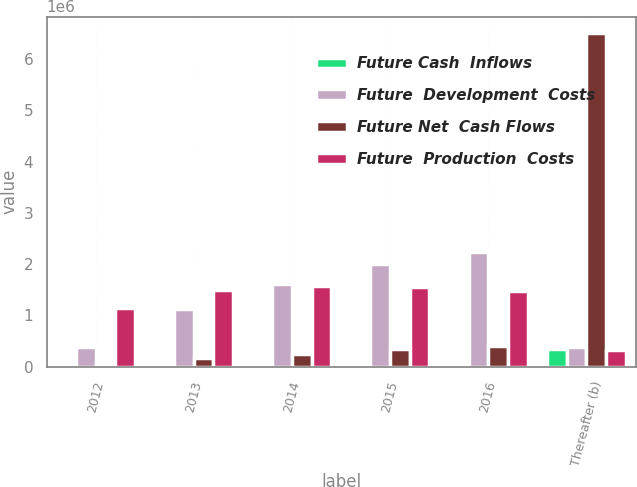<chart> <loc_0><loc_0><loc_500><loc_500><stacked_bar_chart><ecel><fcel>2012<fcel>2013<fcel>2014<fcel>2015<fcel>2016<fcel>Thereafter (b)<nl><fcel>Future Cash  Inflows<fcel>5193<fcel>15707<fcel>23504<fcel>29475<fcel>33783<fcel>335713<nl><fcel>Future  Development  Costs<fcel>385942<fcel>1.11814e+06<fcel>1.60982e+06<fcel>1.99755e+06<fcel>2.22921e+06<fcel>385942<nl><fcel>Future Net  Cash Flows<fcel>55517<fcel>160479<fcel>251653<fcel>336961<fcel>411086<fcel>6.50124e+06<nl><fcel>Future  Production  Costs<fcel>1.1524e+06<fcel>1.48858e+06<fcel>1.57753e+06<fcel>1.54602e+06<fcel>1.46641e+06<fcel>321791<nl></chart> 